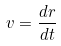Convert formula to latex. <formula><loc_0><loc_0><loc_500><loc_500>v = \frac { d r } { d t }</formula> 